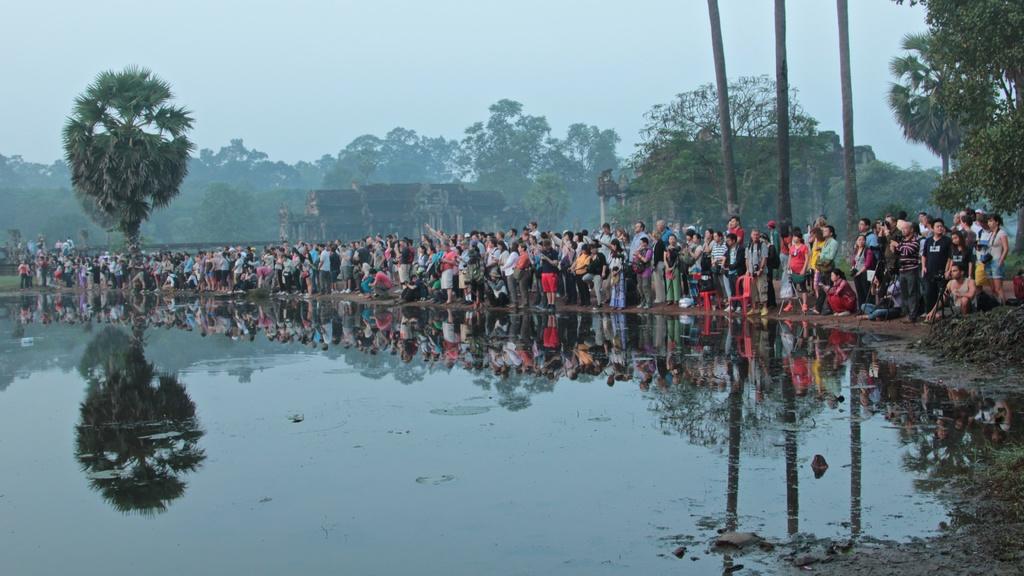Can you describe this image briefly? In the image in the center, we can see water, buildings, trees and a group of people are standing. In the background we can see the sky and clouds. 